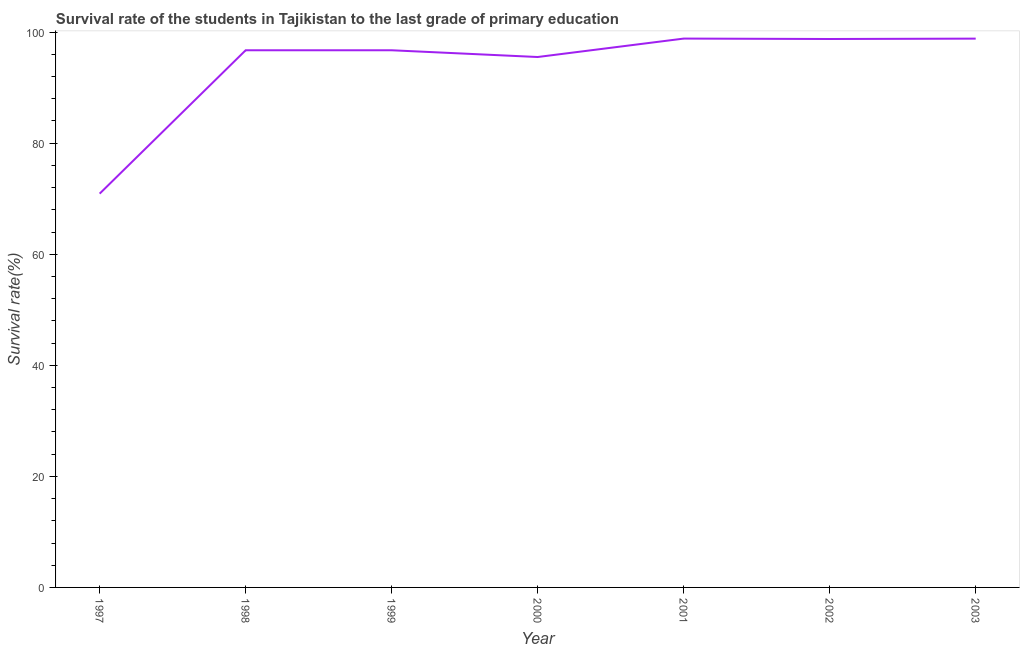What is the survival rate in primary education in 1998?
Make the answer very short. 96.73. Across all years, what is the maximum survival rate in primary education?
Your answer should be compact. 98.83. Across all years, what is the minimum survival rate in primary education?
Make the answer very short. 70.91. In which year was the survival rate in primary education minimum?
Provide a succinct answer. 1997. What is the sum of the survival rate in primary education?
Offer a terse response. 656.31. What is the difference between the survival rate in primary education in 1998 and 2000?
Make the answer very short. 1.22. What is the average survival rate in primary education per year?
Offer a very short reply. 93.76. What is the median survival rate in primary education?
Ensure brevity in your answer.  96.73. In how many years, is the survival rate in primary education greater than 28 %?
Your response must be concise. 7. What is the ratio of the survival rate in primary education in 1999 to that in 2000?
Provide a short and direct response. 1.01. Is the survival rate in primary education in 1999 less than that in 2000?
Provide a short and direct response. No. What is the difference between the highest and the second highest survival rate in primary education?
Offer a terse response. 0.01. Is the sum of the survival rate in primary education in 1997 and 1999 greater than the maximum survival rate in primary education across all years?
Keep it short and to the point. Yes. What is the difference between the highest and the lowest survival rate in primary education?
Ensure brevity in your answer.  27.92. How many years are there in the graph?
Your answer should be compact. 7. Are the values on the major ticks of Y-axis written in scientific E-notation?
Provide a short and direct response. No. What is the title of the graph?
Offer a very short reply. Survival rate of the students in Tajikistan to the last grade of primary education. What is the label or title of the Y-axis?
Provide a short and direct response. Survival rate(%). What is the Survival rate(%) in 1997?
Give a very brief answer. 70.91. What is the Survival rate(%) in 1998?
Your response must be concise. 96.73. What is the Survival rate(%) of 1999?
Your answer should be very brief. 96.73. What is the Survival rate(%) of 2000?
Keep it short and to the point. 95.52. What is the Survival rate(%) of 2001?
Your answer should be compact. 98.83. What is the Survival rate(%) of 2002?
Your answer should be compact. 98.76. What is the Survival rate(%) in 2003?
Ensure brevity in your answer.  98.83. What is the difference between the Survival rate(%) in 1997 and 1998?
Provide a succinct answer. -25.82. What is the difference between the Survival rate(%) in 1997 and 1999?
Give a very brief answer. -25.82. What is the difference between the Survival rate(%) in 1997 and 2000?
Your response must be concise. -24.6. What is the difference between the Survival rate(%) in 1997 and 2001?
Offer a terse response. -27.92. What is the difference between the Survival rate(%) in 1997 and 2002?
Offer a very short reply. -27.85. What is the difference between the Survival rate(%) in 1997 and 2003?
Provide a short and direct response. -27.91. What is the difference between the Survival rate(%) in 1998 and 1999?
Your answer should be very brief. 0. What is the difference between the Survival rate(%) in 1998 and 2000?
Keep it short and to the point. 1.22. What is the difference between the Survival rate(%) in 1998 and 2001?
Your answer should be compact. -2.1. What is the difference between the Survival rate(%) in 1998 and 2002?
Your response must be concise. -2.03. What is the difference between the Survival rate(%) in 1998 and 2003?
Your response must be concise. -2.09. What is the difference between the Survival rate(%) in 1999 and 2000?
Provide a succinct answer. 1.21. What is the difference between the Survival rate(%) in 1999 and 2001?
Ensure brevity in your answer.  -2.11. What is the difference between the Survival rate(%) in 1999 and 2002?
Keep it short and to the point. -2.03. What is the difference between the Survival rate(%) in 1999 and 2003?
Provide a short and direct response. -2.1. What is the difference between the Survival rate(%) in 2000 and 2001?
Offer a terse response. -3.32. What is the difference between the Survival rate(%) in 2000 and 2002?
Your answer should be very brief. -3.24. What is the difference between the Survival rate(%) in 2000 and 2003?
Offer a terse response. -3.31. What is the difference between the Survival rate(%) in 2001 and 2002?
Give a very brief answer. 0.08. What is the difference between the Survival rate(%) in 2001 and 2003?
Ensure brevity in your answer.  0.01. What is the difference between the Survival rate(%) in 2002 and 2003?
Offer a terse response. -0.07. What is the ratio of the Survival rate(%) in 1997 to that in 1998?
Provide a short and direct response. 0.73. What is the ratio of the Survival rate(%) in 1997 to that in 1999?
Offer a very short reply. 0.73. What is the ratio of the Survival rate(%) in 1997 to that in 2000?
Your answer should be compact. 0.74. What is the ratio of the Survival rate(%) in 1997 to that in 2001?
Give a very brief answer. 0.72. What is the ratio of the Survival rate(%) in 1997 to that in 2002?
Make the answer very short. 0.72. What is the ratio of the Survival rate(%) in 1997 to that in 2003?
Offer a very short reply. 0.72. What is the ratio of the Survival rate(%) in 1998 to that in 2000?
Your answer should be very brief. 1.01. What is the ratio of the Survival rate(%) in 1998 to that in 2002?
Offer a very short reply. 0.98. What is the ratio of the Survival rate(%) in 1999 to that in 2000?
Make the answer very short. 1.01. What is the ratio of the Survival rate(%) in 1999 to that in 2003?
Offer a terse response. 0.98. What is the ratio of the Survival rate(%) in 2000 to that in 2001?
Make the answer very short. 0.97. What is the ratio of the Survival rate(%) in 2000 to that in 2002?
Provide a short and direct response. 0.97. What is the ratio of the Survival rate(%) in 2000 to that in 2003?
Provide a short and direct response. 0.97. What is the ratio of the Survival rate(%) in 2001 to that in 2002?
Offer a very short reply. 1. What is the ratio of the Survival rate(%) in 2001 to that in 2003?
Give a very brief answer. 1. What is the ratio of the Survival rate(%) in 2002 to that in 2003?
Keep it short and to the point. 1. 